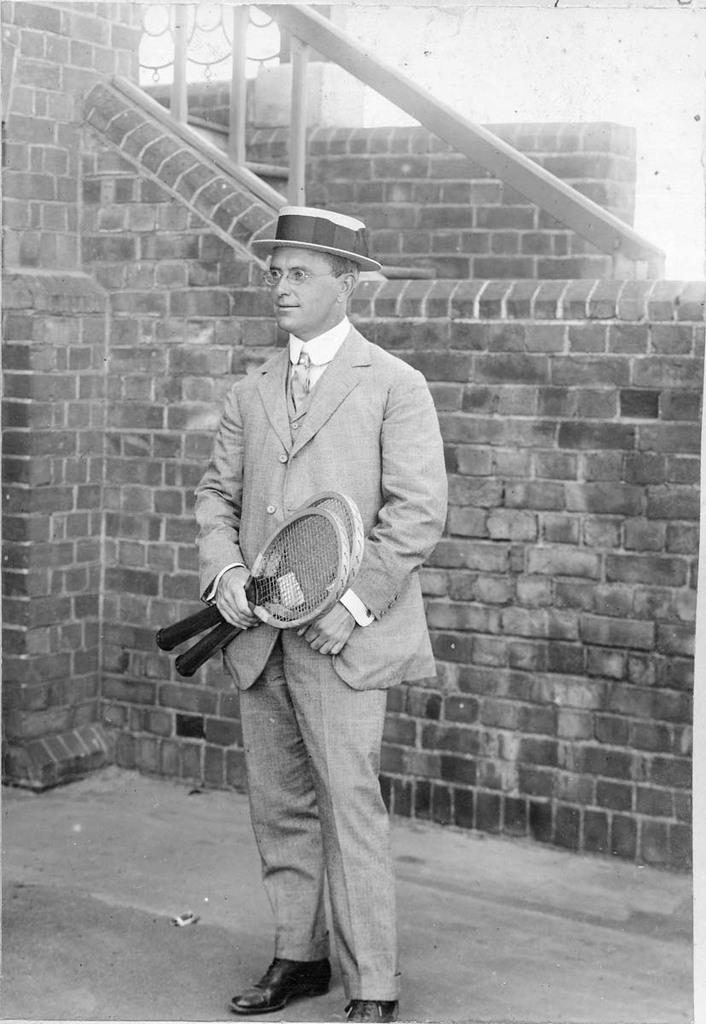Who or what is the main subject in the image? There is a person in the image. What is the person holding in the image? The person is holding two rackets. What type of headwear is the person wearing? The person is wearing a hat. What type of clothing is the person wearing? The person is wearing a suit. What type of background can be seen in the image? There is a brick wall in the image, and the sky is visible. How many eggs are being shown in the image? There are no eggs present in the image. What type of show is the person attending in the image? There is no indication of a show or event in the image. 